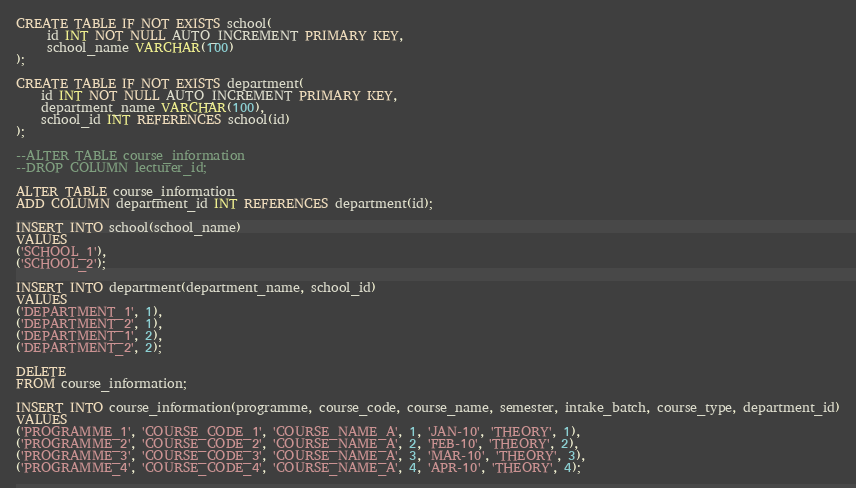Convert code to text. <code><loc_0><loc_0><loc_500><loc_500><_SQL_>CREATE TABLE IF NOT EXISTS school(
     id INT NOT NULL AUTO_INCREMENT PRIMARY KEY,
     school_name VARCHAR(100)
);

CREATE TABLE IF NOT EXISTS department(
    id INT NOT NULL AUTO_INCREMENT PRIMARY KEY,
    department_name VARCHAR(100),
    school_id INT REFERENCES school(id)
);

--ALTER TABLE course_information
--DROP COLUMN lecturer_id;

ALTER TABLE course_information
ADD COLUMN department_id INT REFERENCES department(id);

INSERT INTO school(school_name)
VALUES
('SCHOOL_1'),
('SCHOOL_2');

INSERT INTO department(department_name, school_id)
VALUES
('DEPARTMENT_1', 1),
('DEPARTMENT_2', 1),
('DEPARTMENT_1', 2),
('DEPARTMENT_2', 2);

DELETE
FROM course_information;

INSERT INTO course_information(programme, course_code, course_name, semester, intake_batch, course_type, department_id)
VALUES
('PROGRAMME_1', 'COURSE_CODE_1', 'COURSE_NAME_A', 1, 'JAN-10', 'THEORY', 1),
('PROGRAMME_2', 'COURSE_CODE_2', 'COURSE_NAME_A', 2, 'FEB-10', 'THEORY', 2),
('PROGRAMME_3', 'COURSE_CODE_3', 'COURSE_NAME_A', 3, 'MAR-10', 'THEORY', 3),
('PROGRAMME_4', 'COURSE_CODE_4', 'COURSE_NAME_A', 4, 'APR-10', 'THEORY', 4);</code> 